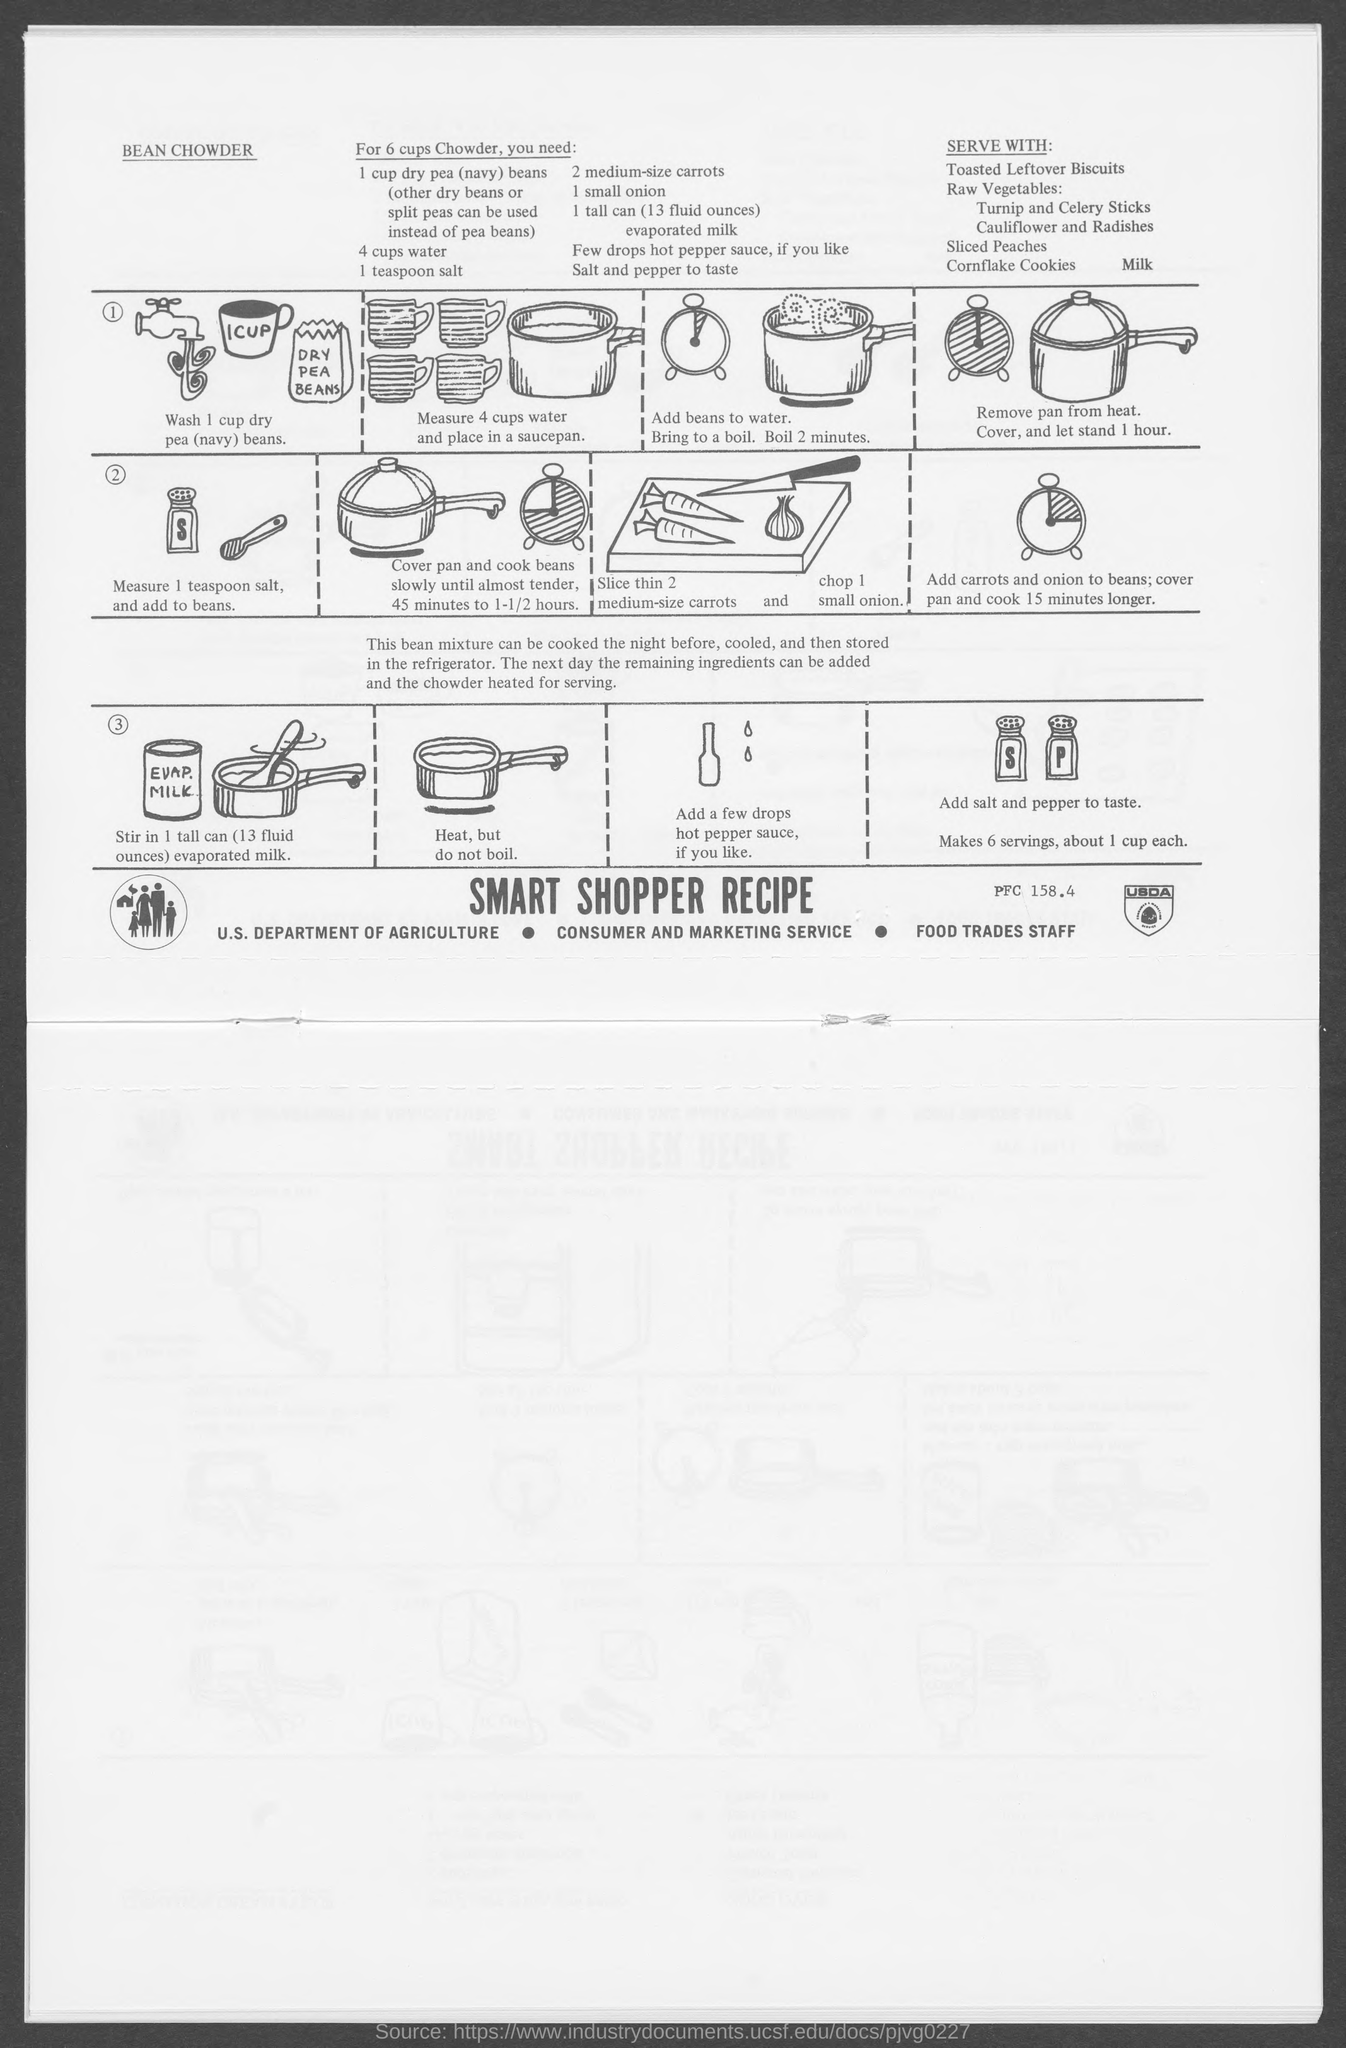What is the recipe for?
Keep it short and to the point. BEAN CHOWDER. How much dry peas?
Your answer should be compact. 1 CUP. How many cups water?
Offer a very short reply. 4. How much evaporated milk?
Your answer should be very brief. 1 tall can. 